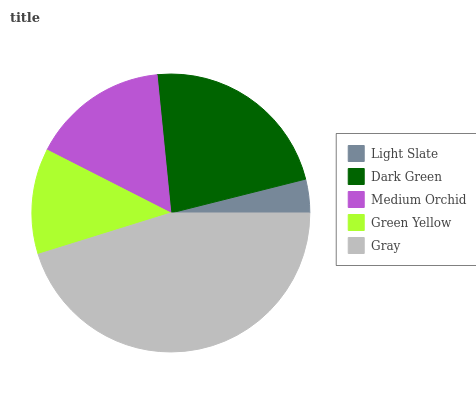Is Light Slate the minimum?
Answer yes or no. Yes. Is Gray the maximum?
Answer yes or no. Yes. Is Dark Green the minimum?
Answer yes or no. No. Is Dark Green the maximum?
Answer yes or no. No. Is Dark Green greater than Light Slate?
Answer yes or no. Yes. Is Light Slate less than Dark Green?
Answer yes or no. Yes. Is Light Slate greater than Dark Green?
Answer yes or no. No. Is Dark Green less than Light Slate?
Answer yes or no. No. Is Medium Orchid the high median?
Answer yes or no. Yes. Is Medium Orchid the low median?
Answer yes or no. Yes. Is Dark Green the high median?
Answer yes or no. No. Is Dark Green the low median?
Answer yes or no. No. 